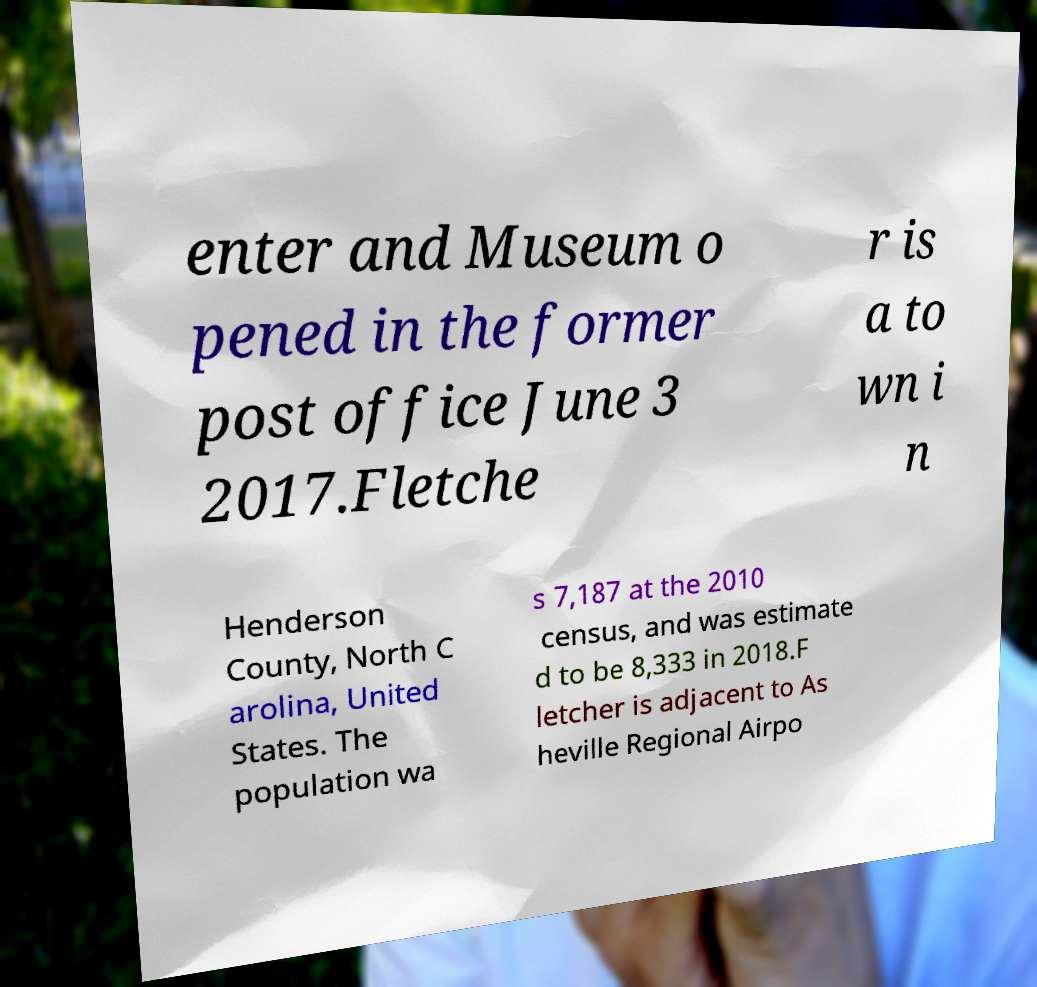Please read and relay the text visible in this image. What does it say? enter and Museum o pened in the former post office June 3 2017.Fletche r is a to wn i n Henderson County, North C arolina, United States. The population wa s 7,187 at the 2010 census, and was estimate d to be 8,333 in 2018.F letcher is adjacent to As heville Regional Airpo 